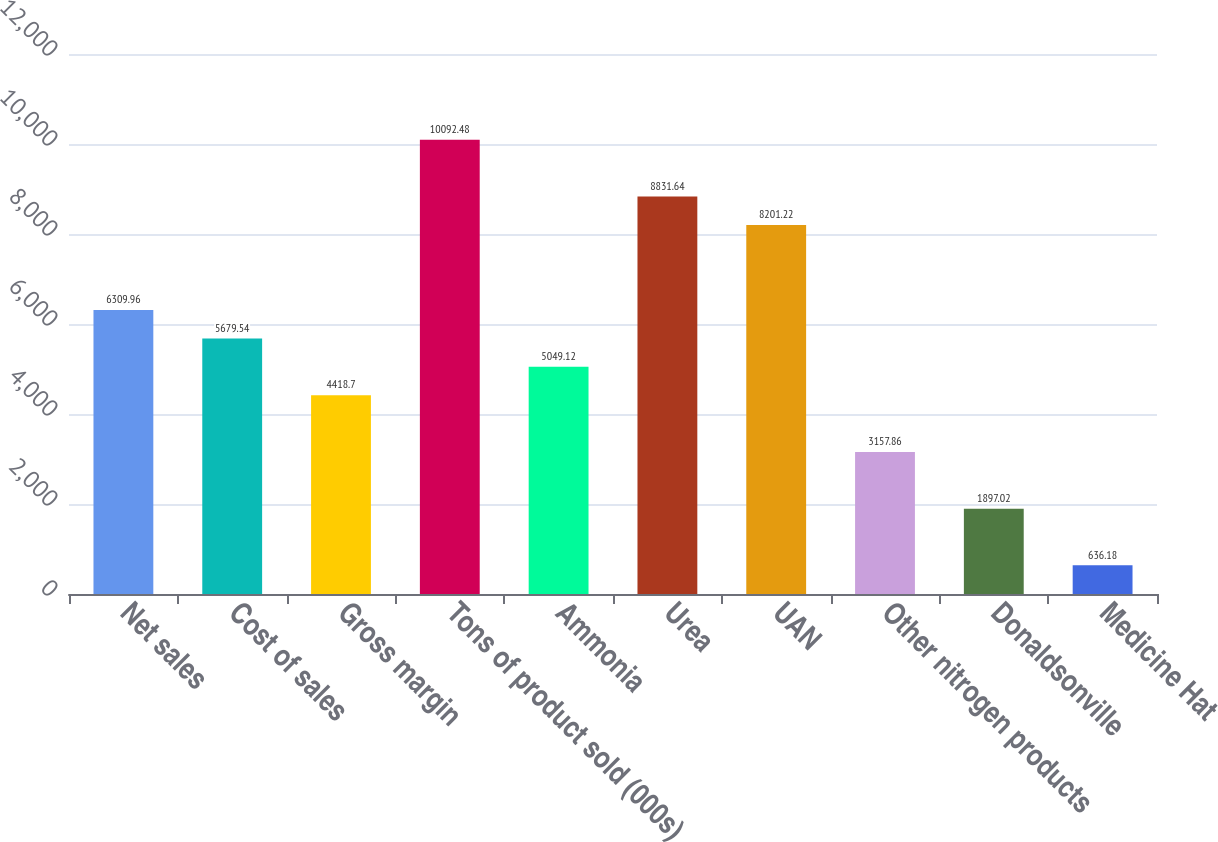Convert chart. <chart><loc_0><loc_0><loc_500><loc_500><bar_chart><fcel>Net sales<fcel>Cost of sales<fcel>Gross margin<fcel>Tons of product sold (000s)<fcel>Ammonia<fcel>Urea<fcel>UAN<fcel>Other nitrogen products<fcel>Donaldsonville<fcel>Medicine Hat<nl><fcel>6309.96<fcel>5679.54<fcel>4418.7<fcel>10092.5<fcel>5049.12<fcel>8831.64<fcel>8201.22<fcel>3157.86<fcel>1897.02<fcel>636.18<nl></chart> 